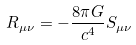Convert formula to latex. <formula><loc_0><loc_0><loc_500><loc_500>R _ { \mu \nu } = - \frac { 8 \pi G } { c ^ { 4 } } S _ { \mu \nu }</formula> 